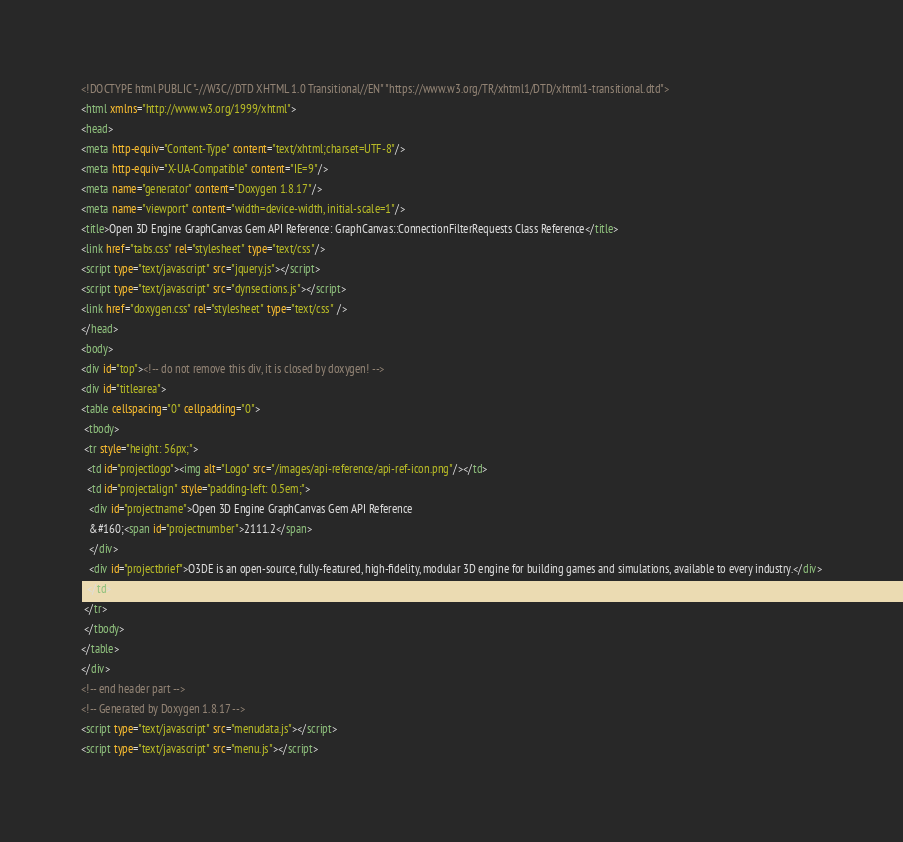<code> <loc_0><loc_0><loc_500><loc_500><_HTML_><!DOCTYPE html PUBLIC "-//W3C//DTD XHTML 1.0 Transitional//EN" "https://www.w3.org/TR/xhtml1/DTD/xhtml1-transitional.dtd">
<html xmlns="http://www.w3.org/1999/xhtml">
<head>
<meta http-equiv="Content-Type" content="text/xhtml;charset=UTF-8"/>
<meta http-equiv="X-UA-Compatible" content="IE=9"/>
<meta name="generator" content="Doxygen 1.8.17"/>
<meta name="viewport" content="width=device-width, initial-scale=1"/>
<title>Open 3D Engine GraphCanvas Gem API Reference: GraphCanvas::ConnectionFilterRequests Class Reference</title>
<link href="tabs.css" rel="stylesheet" type="text/css"/>
<script type="text/javascript" src="jquery.js"></script>
<script type="text/javascript" src="dynsections.js"></script>
<link href="doxygen.css" rel="stylesheet" type="text/css" />
</head>
<body>
<div id="top"><!-- do not remove this div, it is closed by doxygen! -->
<div id="titlearea">
<table cellspacing="0" cellpadding="0">
 <tbody>
 <tr style="height: 56px;">
  <td id="projectlogo"><img alt="Logo" src="/images/api-reference/api-ref-icon.png"/></td>
  <td id="projectalign" style="padding-left: 0.5em;">
   <div id="projectname">Open 3D Engine GraphCanvas Gem API Reference
   &#160;<span id="projectnumber">2111.2</span>
   </div>
   <div id="projectbrief">O3DE is an open-source, fully-featured, high-fidelity, modular 3D engine for building games and simulations, available to every industry.</div>
  </td>
 </tr>
 </tbody>
</table>
</div>
<!-- end header part -->
<!-- Generated by Doxygen 1.8.17 -->
<script type="text/javascript" src="menudata.js"></script>
<script type="text/javascript" src="menu.js"></script></code> 